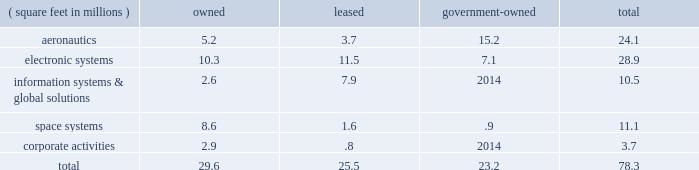The following is a summary of our floor space by business segment at december 31 , 2010 : ( square feet in millions ) owned leased government- owned total .
Some of our owned properties , primarily classified under corporate activities , are leased to third parties .
In the area of manufacturing , most of the operations are of a job-order nature , rather than an assembly line process , and productive equipment has multiple uses for multiple products .
Management believes that all of our major physical facilities are in good condition and are adequate for their intended use .
Item 3 .
Legal proceedings we are a party to or have property subject to litigation and other proceedings , including matters arising under provisions relating to the protection of the environment .
We believe the probability is remote that the outcome of these matters will have a material adverse effect on the corporation as a whole , notwithstanding that the unfavorable resolution of any matter may have a material effect on our net earnings in any particular quarter .
We cannot predict the outcome of legal proceedings with certainty .
These matters include the proceedings summarized in note 14 2013 legal proceedings , commitments , and contingencies beginning on page 78 of this form 10-k .
From time-to-time , agencies of the u.s .
Government investigate whether our operations are being conducted in accordance with applicable regulatory requirements .
U.s .
Government investigations of us , whether relating to government contracts or conducted for other reasons , could result in administrative , civil , or criminal liabilities , including repayments , fines , or penalties being imposed upon us , or could lead to suspension or debarment from future u.s .
Government contracting .
U.s .
Government investigations often take years to complete and many result in no adverse action against us .
We are subject to federal and state requirements for protection of the environment , including those for discharge of hazardous materials and remediation of contaminated sites .
As a result , we are a party to or have our property subject to various lawsuits or proceedings involving environmental protection matters .
Due in part to their complexity and pervasiveness , such requirements have resulted in us being involved with related legal proceedings , claims , and remediation obligations .
The extent of our financial exposure cannot in all cases be reasonably estimated at this time .
For information regarding these matters , including current estimates of the amounts that we believe are required for remediation or clean-up to the extent estimable , see 201ccritical accounting policies 2013 environmental matters 201d in management 2019s discussion and analysis of financial condition and results of operations beginning on page 45 , and note 14 2013 legal proceedings , commitments , and contingencies beginning on page 78 of this form 10-k .
Item 4 .
( removed and reserved ) item 4 ( a ) .
Executive officers of the registrant our executive officers are listed below , as well as information concerning their age at december 31 , 2010 , positions and offices held with the corporation , and principal occupation and business experience over the past five years .
There were no family relationships among any of our executive officers and directors .
All officers serve at the pleasure of the board of directors .
Linda r .
Gooden ( 57 ) , executive vice president 2013 information systems & global solutions ms .
Gooden has served as executive vice president 2013 information systems & global solutions since january 2007 .
She previously served as deputy executive vice president 2013 information & technology services from october 2006 to december 2006 , and president , lockheed martin information technology from september 1997 to december 2006 .
Christopher j .
Gregoire ( 42 ) , vice president and controller ( chief accounting officer ) mr .
Gregoire has served as vice president and controller ( chief accounting officer ) since march 2010 .
He previously was employed by sprint nextel corporation from august 2006 to may 2009 , most recently as principal accounting officer and assistant controller , and was a partner at deloitte & touche llp from september 2003 to july 2006. .
What percentage of total floor space by business segment at december 31 , 2010 is leased? 
Computations: (25.5 / 78.3)
Answer: 0.32567. The following is a summary of our floor space by business segment at december 31 , 2010 : ( square feet in millions ) owned leased government- owned total .
Some of our owned properties , primarily classified under corporate activities , are leased to third parties .
In the area of manufacturing , most of the operations are of a job-order nature , rather than an assembly line process , and productive equipment has multiple uses for multiple products .
Management believes that all of our major physical facilities are in good condition and are adequate for their intended use .
Item 3 .
Legal proceedings we are a party to or have property subject to litigation and other proceedings , including matters arising under provisions relating to the protection of the environment .
We believe the probability is remote that the outcome of these matters will have a material adverse effect on the corporation as a whole , notwithstanding that the unfavorable resolution of any matter may have a material effect on our net earnings in any particular quarter .
We cannot predict the outcome of legal proceedings with certainty .
These matters include the proceedings summarized in note 14 2013 legal proceedings , commitments , and contingencies beginning on page 78 of this form 10-k .
From time-to-time , agencies of the u.s .
Government investigate whether our operations are being conducted in accordance with applicable regulatory requirements .
U.s .
Government investigations of us , whether relating to government contracts or conducted for other reasons , could result in administrative , civil , or criminal liabilities , including repayments , fines , or penalties being imposed upon us , or could lead to suspension or debarment from future u.s .
Government contracting .
U.s .
Government investigations often take years to complete and many result in no adverse action against us .
We are subject to federal and state requirements for protection of the environment , including those for discharge of hazardous materials and remediation of contaminated sites .
As a result , we are a party to or have our property subject to various lawsuits or proceedings involving environmental protection matters .
Due in part to their complexity and pervasiveness , such requirements have resulted in us being involved with related legal proceedings , claims , and remediation obligations .
The extent of our financial exposure cannot in all cases be reasonably estimated at this time .
For information regarding these matters , including current estimates of the amounts that we believe are required for remediation or clean-up to the extent estimable , see 201ccritical accounting policies 2013 environmental matters 201d in management 2019s discussion and analysis of financial condition and results of operations beginning on page 45 , and note 14 2013 legal proceedings , commitments , and contingencies beginning on page 78 of this form 10-k .
Item 4 .
( removed and reserved ) item 4 ( a ) .
Executive officers of the registrant our executive officers are listed below , as well as information concerning their age at december 31 , 2010 , positions and offices held with the corporation , and principal occupation and business experience over the past five years .
There were no family relationships among any of our executive officers and directors .
All officers serve at the pleasure of the board of directors .
Linda r .
Gooden ( 57 ) , executive vice president 2013 information systems & global solutions ms .
Gooden has served as executive vice president 2013 information systems & global solutions since january 2007 .
She previously served as deputy executive vice president 2013 information & technology services from october 2006 to december 2006 , and president , lockheed martin information technology from september 1997 to december 2006 .
Christopher j .
Gregoire ( 42 ) , vice president and controller ( chief accounting officer ) mr .
Gregoire has served as vice president and controller ( chief accounting officer ) since march 2010 .
He previously was employed by sprint nextel corporation from august 2006 to may 2009 , most recently as principal accounting officer and assistant controller , and was a partner at deloitte & touche llp from september 2003 to july 2006. .
What portion of the total floor space is owned by the company? 
Computations: (29.6 / 78.3)
Answer: 0.37803. The following is a summary of our floor space by business segment at december 31 , 2010 : ( square feet in millions ) owned leased government- owned total .
Some of our owned properties , primarily classified under corporate activities , are leased to third parties .
In the area of manufacturing , most of the operations are of a job-order nature , rather than an assembly line process , and productive equipment has multiple uses for multiple products .
Management believes that all of our major physical facilities are in good condition and are adequate for their intended use .
Item 3 .
Legal proceedings we are a party to or have property subject to litigation and other proceedings , including matters arising under provisions relating to the protection of the environment .
We believe the probability is remote that the outcome of these matters will have a material adverse effect on the corporation as a whole , notwithstanding that the unfavorable resolution of any matter may have a material effect on our net earnings in any particular quarter .
We cannot predict the outcome of legal proceedings with certainty .
These matters include the proceedings summarized in note 14 2013 legal proceedings , commitments , and contingencies beginning on page 78 of this form 10-k .
From time-to-time , agencies of the u.s .
Government investigate whether our operations are being conducted in accordance with applicable regulatory requirements .
U.s .
Government investigations of us , whether relating to government contracts or conducted for other reasons , could result in administrative , civil , or criminal liabilities , including repayments , fines , or penalties being imposed upon us , or could lead to suspension or debarment from future u.s .
Government contracting .
U.s .
Government investigations often take years to complete and many result in no adverse action against us .
We are subject to federal and state requirements for protection of the environment , including those for discharge of hazardous materials and remediation of contaminated sites .
As a result , we are a party to or have our property subject to various lawsuits or proceedings involving environmental protection matters .
Due in part to their complexity and pervasiveness , such requirements have resulted in us being involved with related legal proceedings , claims , and remediation obligations .
The extent of our financial exposure cannot in all cases be reasonably estimated at this time .
For information regarding these matters , including current estimates of the amounts that we believe are required for remediation or clean-up to the extent estimable , see 201ccritical accounting policies 2013 environmental matters 201d in management 2019s discussion and analysis of financial condition and results of operations beginning on page 45 , and note 14 2013 legal proceedings , commitments , and contingencies beginning on page 78 of this form 10-k .
Item 4 .
( removed and reserved ) item 4 ( a ) .
Executive officers of the registrant our executive officers are listed below , as well as information concerning their age at december 31 , 2010 , positions and offices held with the corporation , and principal occupation and business experience over the past five years .
There were no family relationships among any of our executive officers and directors .
All officers serve at the pleasure of the board of directors .
Linda r .
Gooden ( 57 ) , executive vice president 2013 information systems & global solutions ms .
Gooden has served as executive vice president 2013 information systems & global solutions since january 2007 .
She previously served as deputy executive vice president 2013 information & technology services from october 2006 to december 2006 , and president , lockheed martin information technology from september 1997 to december 2006 .
Christopher j .
Gregoire ( 42 ) , vice president and controller ( chief accounting officer ) mr .
Gregoire has served as vice president and controller ( chief accounting officer ) since march 2010 .
He previously was employed by sprint nextel corporation from august 2006 to may 2009 , most recently as principal accounting officer and assistant controller , and was a partner at deloitte & touche llp from september 2003 to july 2006. .
What portion of the total floor space is used by aeronautics? 
Computations: (24.1 / 78.3)
Answer: 0.30779. 